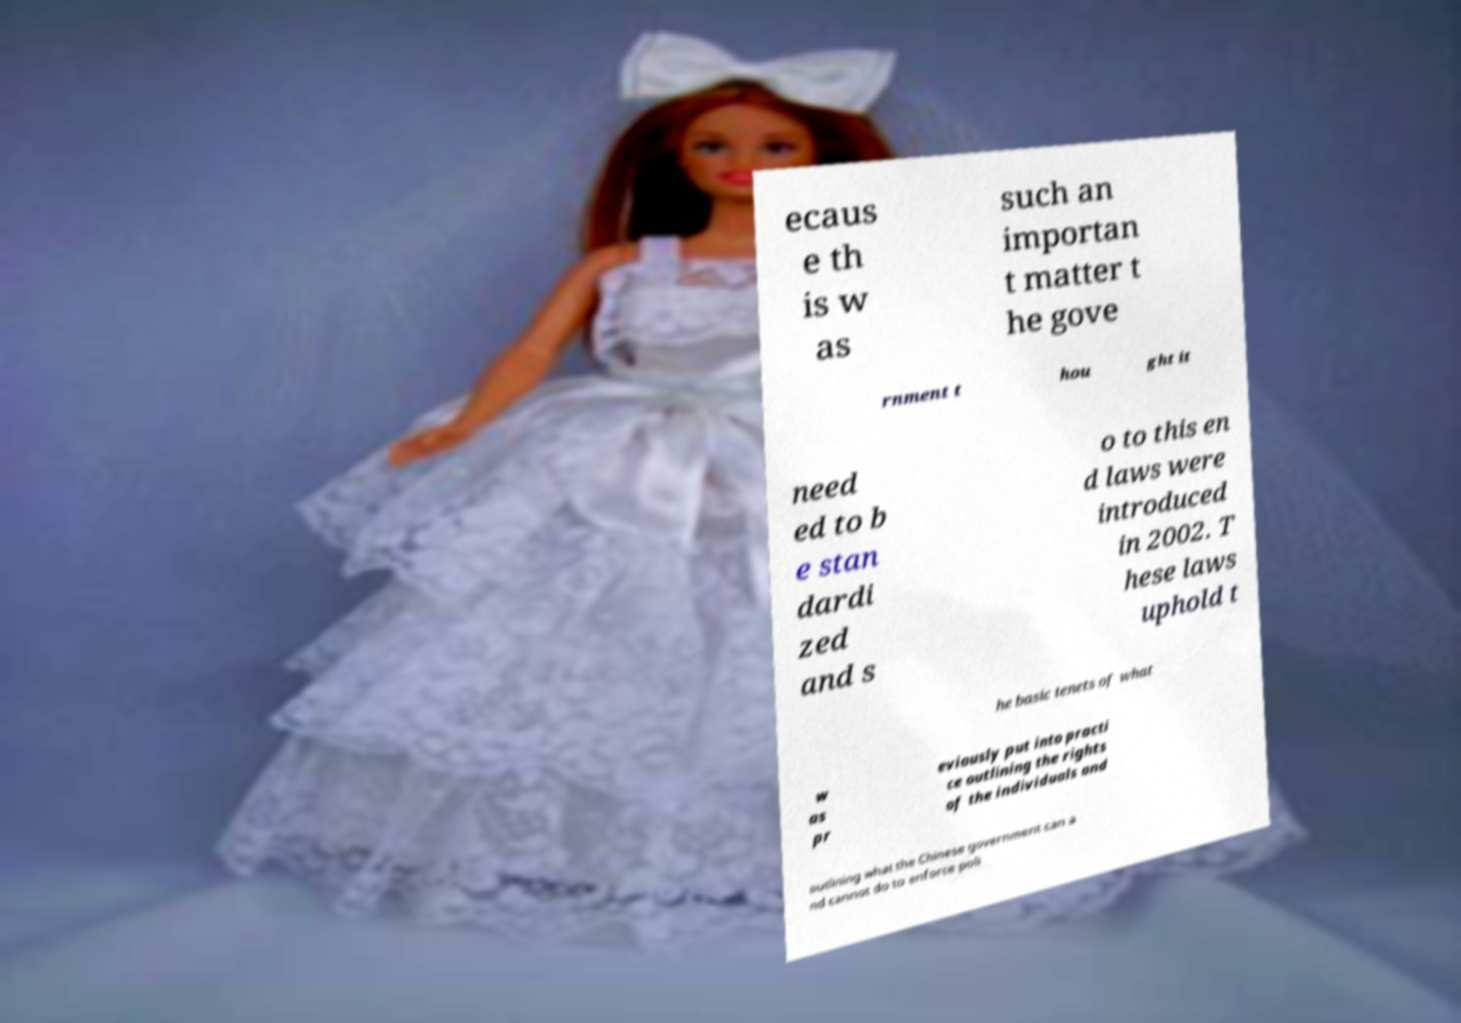Please read and relay the text visible in this image. What does it say? ecaus e th is w as such an importan t matter t he gove rnment t hou ght it need ed to b e stan dardi zed and s o to this en d laws were introduced in 2002. T hese laws uphold t he basic tenets of what w as pr eviously put into practi ce outlining the rights of the individuals and outlining what the Chinese government can a nd cannot do to enforce poli 